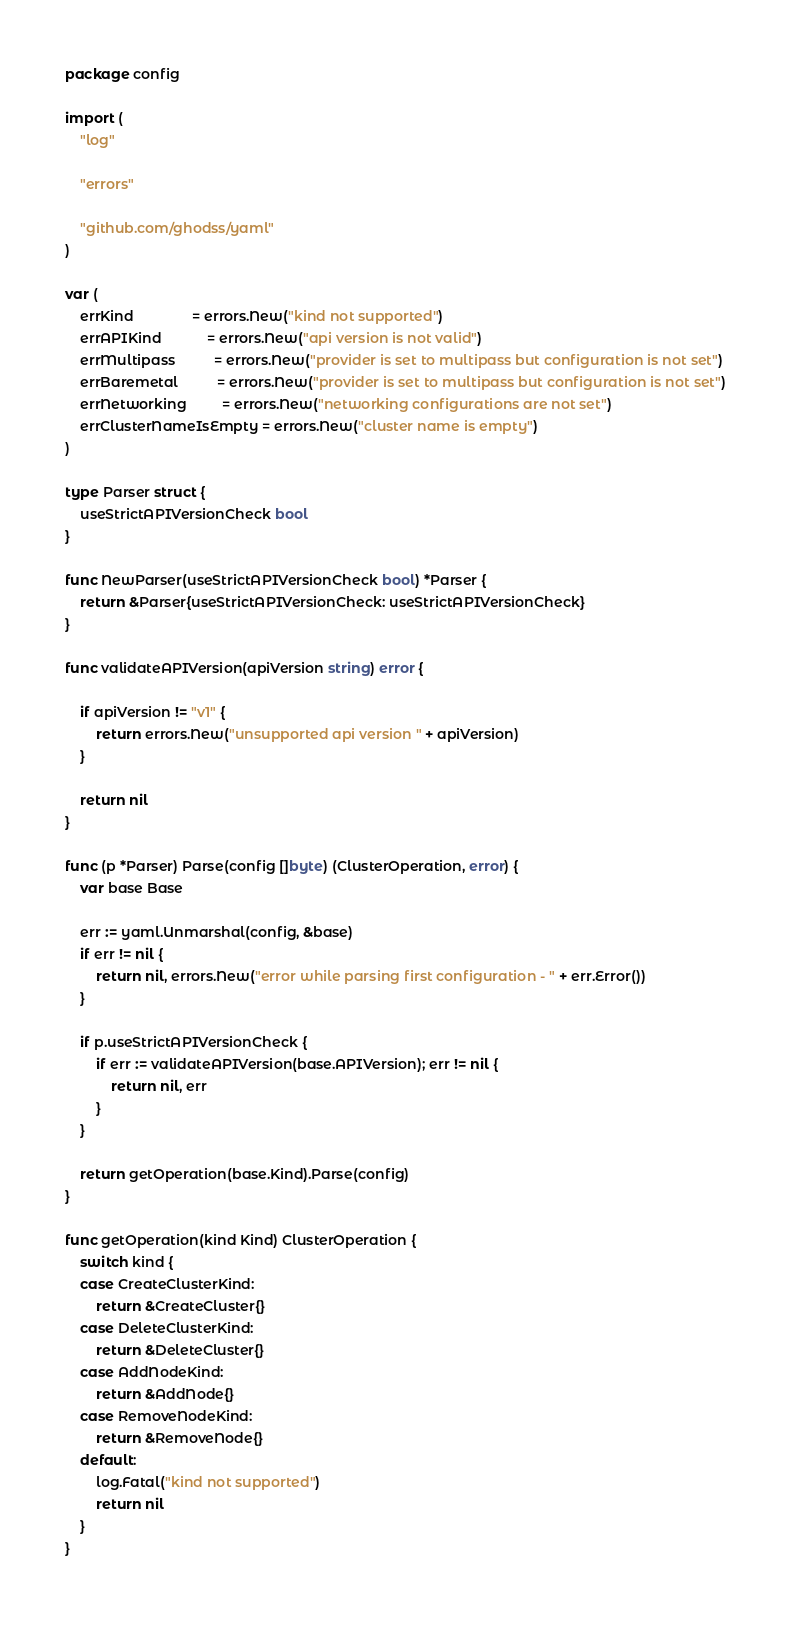Convert code to text. <code><loc_0><loc_0><loc_500><loc_500><_Go_>package config

import (
	"log"

	"errors"

	"github.com/ghodss/yaml"
)

var (
	errKind               = errors.New("kind not supported")
	errAPIKind            = errors.New("api version is not valid")
	errMultipass          = errors.New("provider is set to multipass but configuration is not set")
	errBaremetal          = errors.New("provider is set to multipass but configuration is not set")
	errNetworking         = errors.New("networking configurations are not set")
	errClusterNameIsEmpty = errors.New("cluster name is empty")
)

type Parser struct {
	useStrictAPIVersionCheck bool
}

func NewParser(useStrictAPIVersionCheck bool) *Parser {
	return &Parser{useStrictAPIVersionCheck: useStrictAPIVersionCheck}
}

func validateAPIVersion(apiVersion string) error {

	if apiVersion != "v1" {
		return errors.New("unsupported api version " + apiVersion)
	}

	return nil
}

func (p *Parser) Parse(config []byte) (ClusterOperation, error) {
	var base Base

	err := yaml.Unmarshal(config, &base)
	if err != nil {
		return nil, errors.New("error while parsing first configuration - " + err.Error())
	}

	if p.useStrictAPIVersionCheck {
		if err := validateAPIVersion(base.APIVersion); err != nil {
			return nil, err
		}
	}

	return getOperation(base.Kind).Parse(config)
}

func getOperation(kind Kind) ClusterOperation {
	switch kind {
	case CreateClusterKind:
		return &CreateCluster{}
	case DeleteClusterKind:
		return &DeleteCluster{}
	case AddNodeKind:
		return &AddNode{}
	case RemoveNodeKind:
		return &RemoveNode{}
	default:
		log.Fatal("kind not supported")
		return nil
	}
}
</code> 